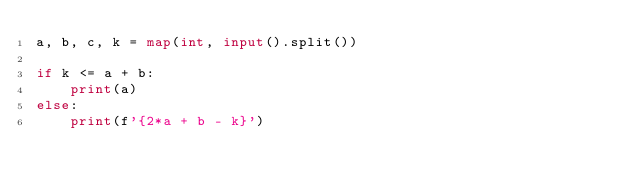Convert code to text. <code><loc_0><loc_0><loc_500><loc_500><_Python_>a, b, c, k = map(int, input().split())

if k <= a + b:
    print(a)
else:
    print(f'{2*a + b - k}')</code> 